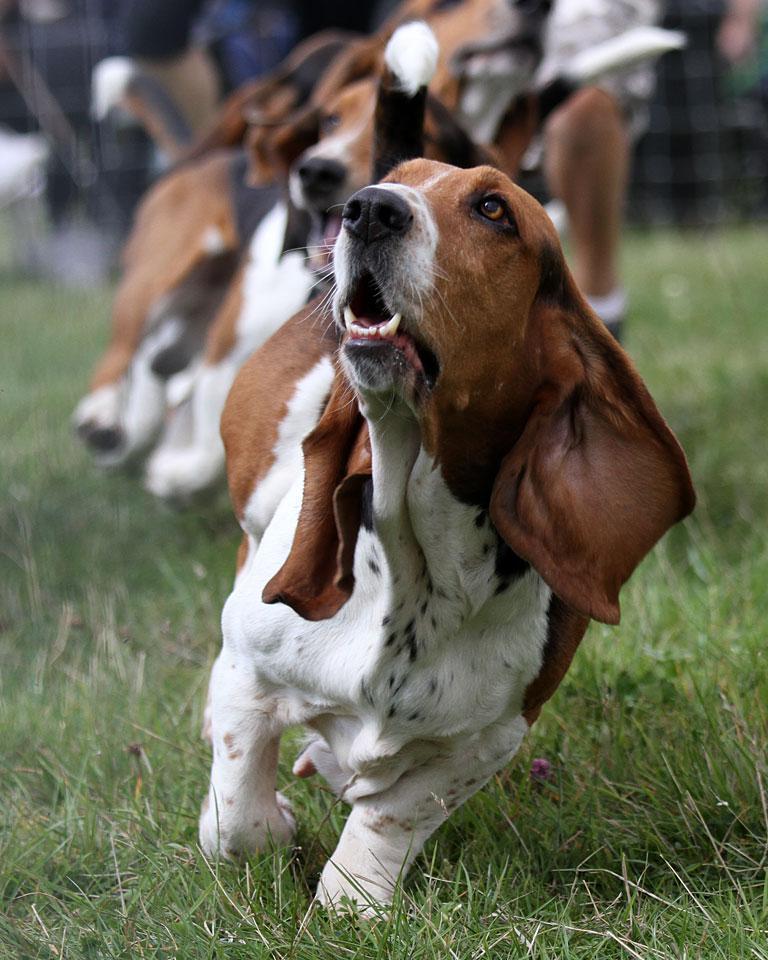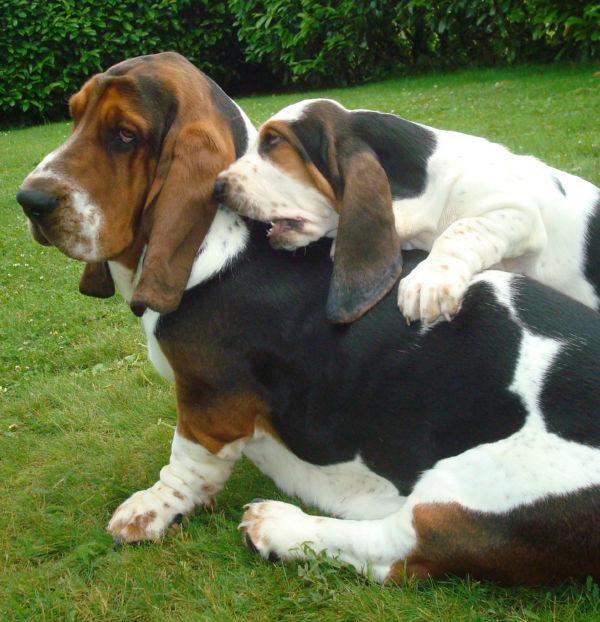The first image is the image on the left, the second image is the image on the right. Examine the images to the left and right. Is the description "There are 2 dogs outdoors on the grass." accurate? Answer yes or no. No. The first image is the image on the left, the second image is the image on the right. Considering the images on both sides, is "One of the images shows a basset hound with its body pointed toward the right." valid? Answer yes or no. No. 